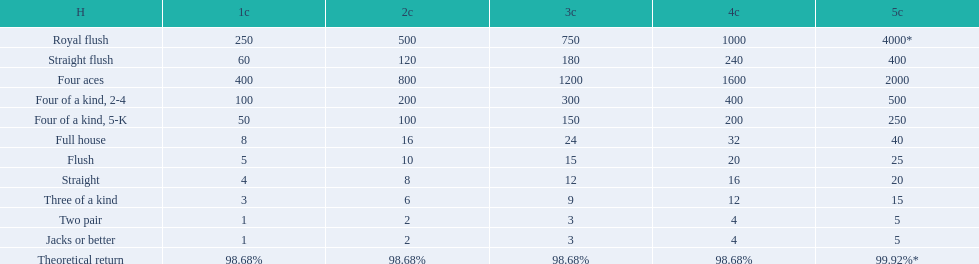What is the total amount of a 3 credit straight flush? 180. 